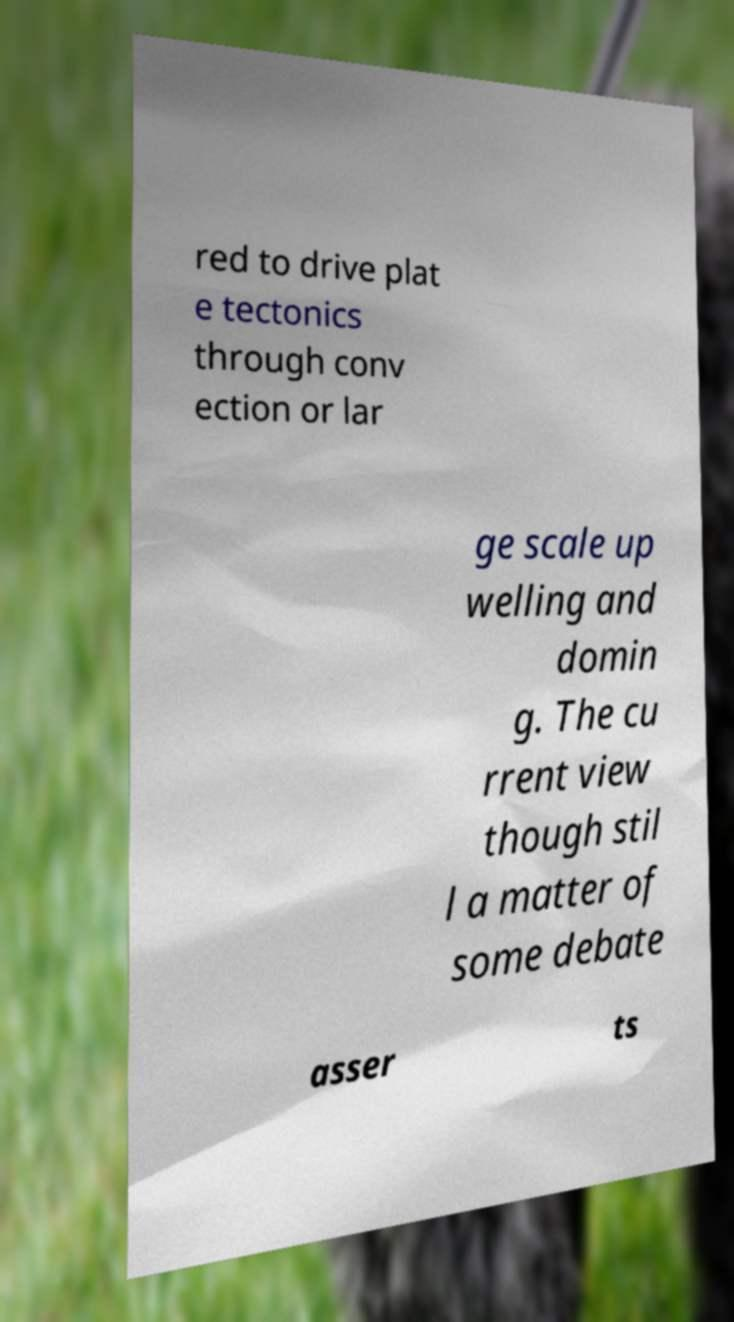Could you assist in decoding the text presented in this image and type it out clearly? red to drive plat e tectonics through conv ection or lar ge scale up welling and domin g. The cu rrent view though stil l a matter of some debate asser ts 